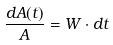Convert formula to latex. <formula><loc_0><loc_0><loc_500><loc_500>\frac { d A ( t ) } { A } = W \cdot d t</formula> 